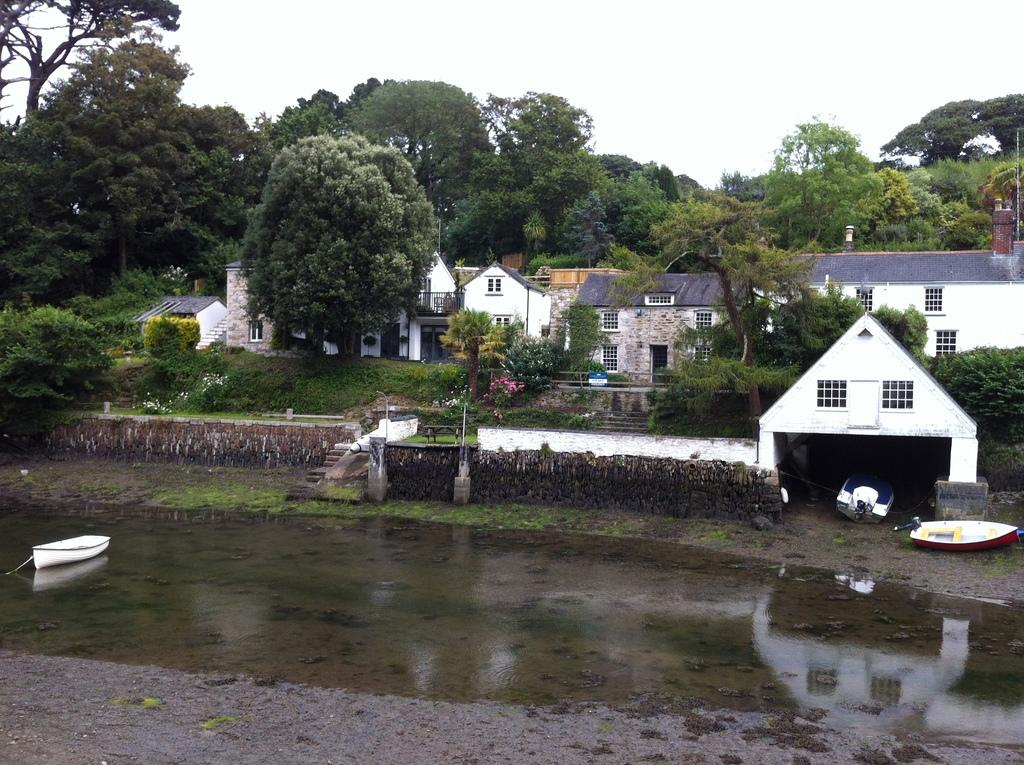What type of structures can be seen in the background of the image? There are houses in the background of the image. What other natural elements are present in the background? There are trees in the background of the image. What is visible at the bottom of the image? There is water visible at the bottom of the image. What is floating on the water? There is a boat in the water. What is visible at the top of the image? The sky is visible at the top of the image. How many rabbits can be seen forming a circle in the water? There are no rabbits present in the image, and therefore no such formation can be observed. 